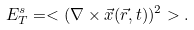Convert formula to latex. <formula><loc_0><loc_0><loc_500><loc_500>E ^ { s } _ { T } = < ( \nabla \times \vec { x } ( \vec { r } , t ) ) ^ { 2 } > .</formula> 